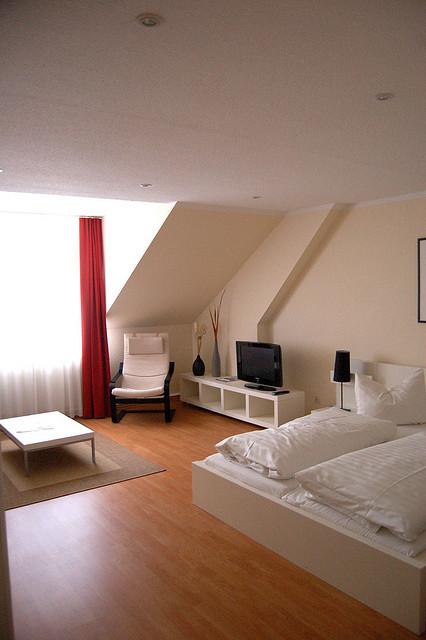What type of floor is this?
Answer briefly. Wood. What color are the curtains on the end?
Write a very short answer. Red. How many people can sleep in this room?
Be succinct. 2. What is the color of the bedding?
Short answer required. White. Are there curtains on the windows?
Quick response, please. Yes. What color is the bedspread?
Write a very short answer. White. 